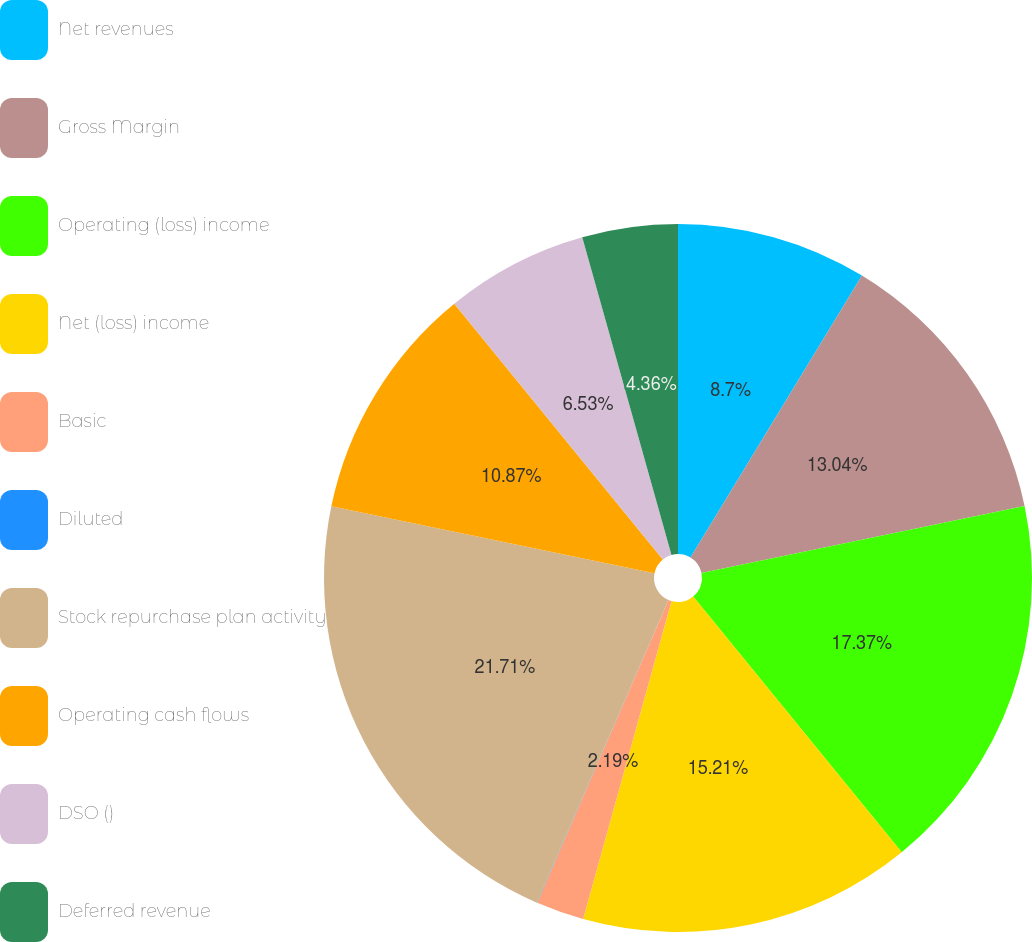<chart> <loc_0><loc_0><loc_500><loc_500><pie_chart><fcel>Net revenues<fcel>Gross Margin<fcel>Operating (loss) income<fcel>Net (loss) income<fcel>Basic<fcel>Diluted<fcel>Stock repurchase plan activity<fcel>Operating cash flows<fcel>DSO ()<fcel>Deferred revenue<nl><fcel>8.7%<fcel>13.04%<fcel>17.38%<fcel>15.21%<fcel>2.19%<fcel>0.02%<fcel>21.72%<fcel>10.87%<fcel>6.53%<fcel>4.36%<nl></chart> 